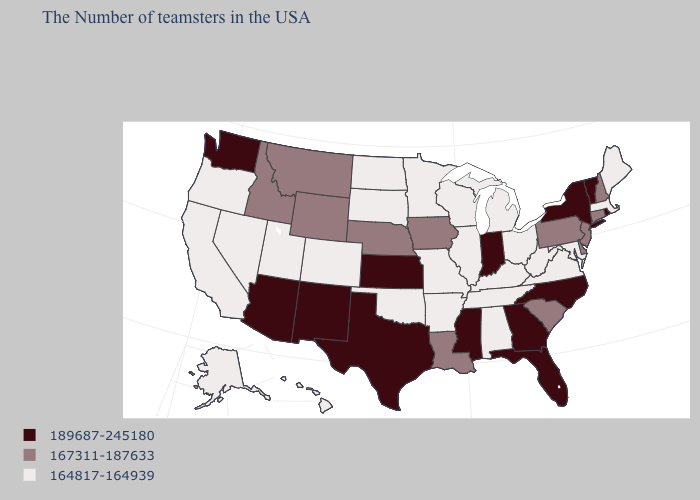Which states have the lowest value in the South?
Keep it brief. Maryland, Virginia, West Virginia, Kentucky, Alabama, Tennessee, Arkansas, Oklahoma. Among the states that border Minnesota , which have the lowest value?
Answer briefly. Wisconsin, South Dakota, North Dakota. Among the states that border Arizona , does California have the lowest value?
Write a very short answer. Yes. Among the states that border South Dakota , does North Dakota have the lowest value?
Short answer required. Yes. Name the states that have a value in the range 164817-164939?
Answer briefly. Maine, Massachusetts, Maryland, Virginia, West Virginia, Ohio, Michigan, Kentucky, Alabama, Tennessee, Wisconsin, Illinois, Missouri, Arkansas, Minnesota, Oklahoma, South Dakota, North Dakota, Colorado, Utah, Nevada, California, Oregon, Alaska, Hawaii. What is the value of Florida?
Keep it brief. 189687-245180. What is the lowest value in the MidWest?
Write a very short answer. 164817-164939. What is the highest value in the Northeast ?
Short answer required. 189687-245180. Name the states that have a value in the range 189687-245180?
Concise answer only. Rhode Island, Vermont, New York, North Carolina, Florida, Georgia, Indiana, Mississippi, Kansas, Texas, New Mexico, Arizona, Washington. What is the highest value in the South ?
Write a very short answer. 189687-245180. What is the value of California?
Short answer required. 164817-164939. Which states hav the highest value in the MidWest?
Write a very short answer. Indiana, Kansas. What is the value of Nebraska?
Concise answer only. 167311-187633. Among the states that border Illinois , which have the highest value?
Write a very short answer. Indiana. Among the states that border Delaware , does New Jersey have the highest value?
Answer briefly. Yes. 